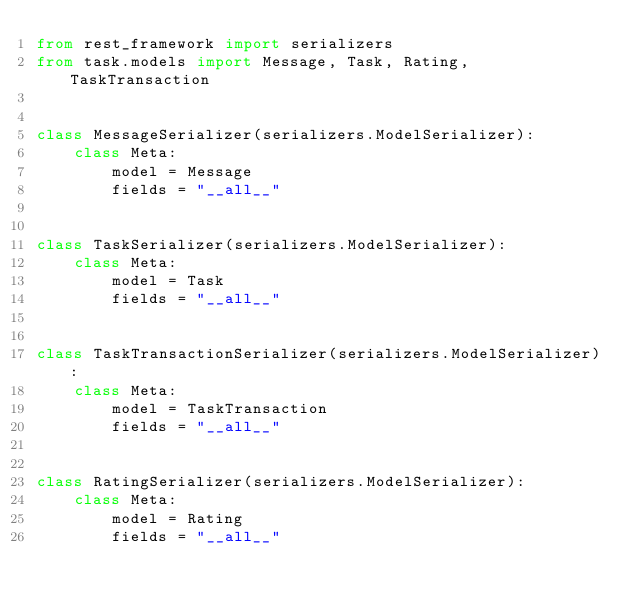<code> <loc_0><loc_0><loc_500><loc_500><_Python_>from rest_framework import serializers
from task.models import Message, Task, Rating, TaskTransaction


class MessageSerializer(serializers.ModelSerializer):
    class Meta:
        model = Message
        fields = "__all__"


class TaskSerializer(serializers.ModelSerializer):
    class Meta:
        model = Task
        fields = "__all__"


class TaskTransactionSerializer(serializers.ModelSerializer):
    class Meta:
        model = TaskTransaction
        fields = "__all__"


class RatingSerializer(serializers.ModelSerializer):
    class Meta:
        model = Rating
        fields = "__all__"
</code> 